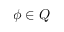<formula> <loc_0><loc_0><loc_500><loc_500>\phi \in Q</formula> 